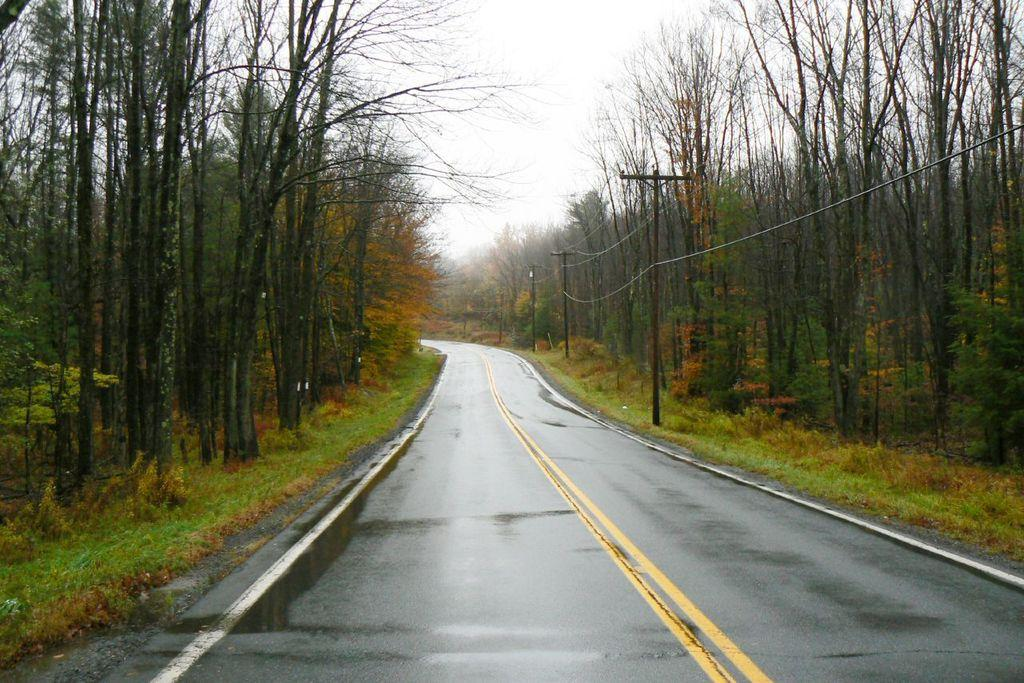What is the main feature of the image? There is a road in the image. What is on the road? There is water on the road, as well as poles and wires. What type of vegetation can be seen in the image? There are trees visible in the image, and there is also grass. What is visible in the background of the image? The sky is visible in the background of the image. What type of leather can be seen on the chessboard in the image? There is no chessboard or leather present in the image; it features a road with water, poles, wires, trees, grass, and a visible sky. 